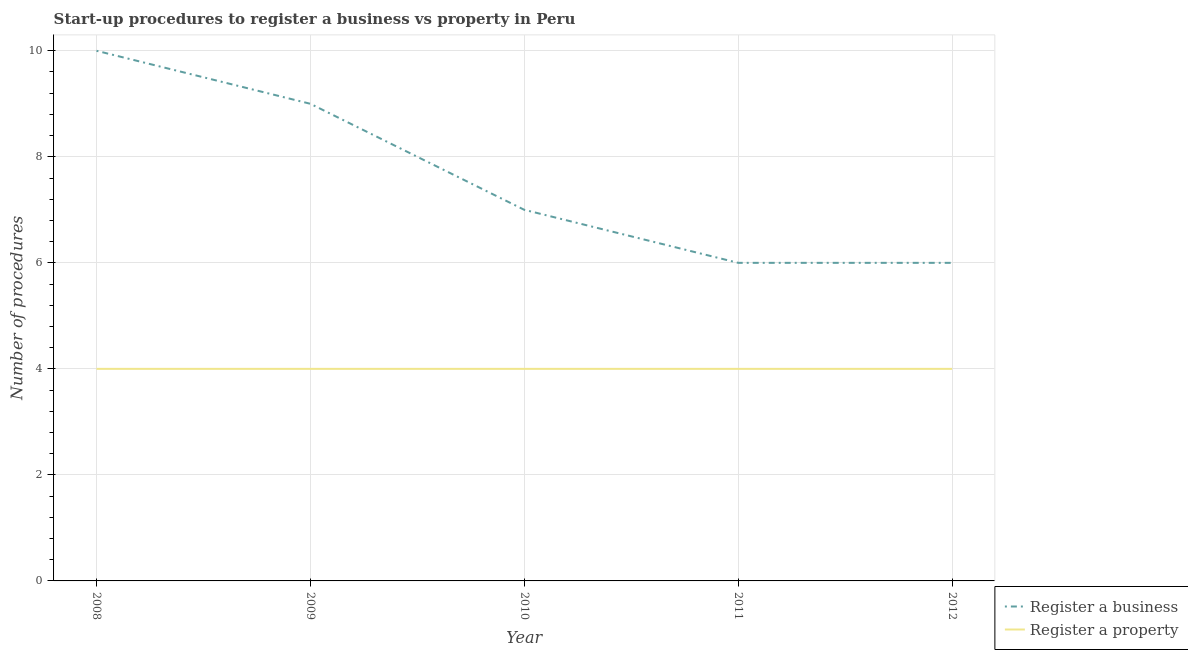How many different coloured lines are there?
Your response must be concise. 2. Is the number of lines equal to the number of legend labels?
Make the answer very short. Yes. Across all years, what is the maximum number of procedures to register a property?
Ensure brevity in your answer.  4. What is the total number of procedures to register a business in the graph?
Provide a succinct answer. 38. What is the difference between the number of procedures to register a business in 2011 and that in 2012?
Provide a short and direct response. 0. What is the average number of procedures to register a property per year?
Provide a short and direct response. 4. In the year 2011, what is the difference between the number of procedures to register a business and number of procedures to register a property?
Ensure brevity in your answer.  2. What is the ratio of the number of procedures to register a business in 2009 to that in 2010?
Give a very brief answer. 1.29. Is the number of procedures to register a property in 2011 less than that in 2012?
Give a very brief answer. No. Is the difference between the number of procedures to register a property in 2008 and 2011 greater than the difference between the number of procedures to register a business in 2008 and 2011?
Keep it short and to the point. No. What is the difference between the highest and the lowest number of procedures to register a business?
Your answer should be very brief. 4. In how many years, is the number of procedures to register a business greater than the average number of procedures to register a business taken over all years?
Offer a very short reply. 2. Does the number of procedures to register a business monotonically increase over the years?
Make the answer very short. No. Is the number of procedures to register a business strictly less than the number of procedures to register a property over the years?
Make the answer very short. No. How many lines are there?
Provide a short and direct response. 2. How many years are there in the graph?
Your answer should be very brief. 5. Are the values on the major ticks of Y-axis written in scientific E-notation?
Your answer should be very brief. No. Where does the legend appear in the graph?
Your response must be concise. Bottom right. How are the legend labels stacked?
Your answer should be compact. Vertical. What is the title of the graph?
Ensure brevity in your answer.  Start-up procedures to register a business vs property in Peru. What is the label or title of the X-axis?
Keep it short and to the point. Year. What is the label or title of the Y-axis?
Give a very brief answer. Number of procedures. What is the Number of procedures in Register a business in 2008?
Give a very brief answer. 10. What is the Number of procedures of Register a business in 2009?
Your answer should be very brief. 9. What is the Number of procedures of Register a property in 2009?
Offer a terse response. 4. What is the Number of procedures of Register a property in 2010?
Provide a succinct answer. 4. What is the Number of procedures in Register a business in 2011?
Your response must be concise. 6. What is the Number of procedures in Register a property in 2011?
Keep it short and to the point. 4. What is the Number of procedures in Register a business in 2012?
Offer a terse response. 6. What is the Number of procedures of Register a property in 2012?
Your answer should be compact. 4. Across all years, what is the maximum Number of procedures in Register a business?
Make the answer very short. 10. Across all years, what is the maximum Number of procedures of Register a property?
Give a very brief answer. 4. Across all years, what is the minimum Number of procedures of Register a business?
Provide a short and direct response. 6. Across all years, what is the minimum Number of procedures of Register a property?
Offer a very short reply. 4. What is the total Number of procedures of Register a business in the graph?
Provide a succinct answer. 38. What is the difference between the Number of procedures in Register a property in 2008 and that in 2011?
Your answer should be very brief. 0. What is the difference between the Number of procedures in Register a property in 2008 and that in 2012?
Make the answer very short. 0. What is the difference between the Number of procedures of Register a property in 2009 and that in 2010?
Provide a succinct answer. 0. What is the difference between the Number of procedures in Register a business in 2009 and that in 2011?
Offer a terse response. 3. What is the difference between the Number of procedures of Register a property in 2009 and that in 2012?
Keep it short and to the point. 0. What is the difference between the Number of procedures in Register a business in 2010 and that in 2011?
Provide a short and direct response. 1. What is the difference between the Number of procedures in Register a business in 2010 and that in 2012?
Provide a short and direct response. 1. What is the difference between the Number of procedures of Register a property in 2010 and that in 2012?
Your response must be concise. 0. What is the difference between the Number of procedures in Register a business in 2011 and that in 2012?
Offer a terse response. 0. What is the difference between the Number of procedures of Register a business in 2008 and the Number of procedures of Register a property in 2011?
Your response must be concise. 6. What is the difference between the Number of procedures of Register a business in 2010 and the Number of procedures of Register a property in 2011?
Keep it short and to the point. 3. What is the average Number of procedures of Register a property per year?
Ensure brevity in your answer.  4. What is the ratio of the Number of procedures of Register a business in 2008 to that in 2009?
Give a very brief answer. 1.11. What is the ratio of the Number of procedures of Register a business in 2008 to that in 2010?
Offer a very short reply. 1.43. What is the ratio of the Number of procedures in Register a business in 2008 to that in 2011?
Make the answer very short. 1.67. What is the ratio of the Number of procedures of Register a property in 2008 to that in 2011?
Make the answer very short. 1. What is the ratio of the Number of procedures of Register a business in 2008 to that in 2012?
Your answer should be very brief. 1.67. What is the ratio of the Number of procedures in Register a business in 2009 to that in 2010?
Ensure brevity in your answer.  1.29. What is the ratio of the Number of procedures in Register a property in 2009 to that in 2010?
Provide a succinct answer. 1. What is the ratio of the Number of procedures of Register a property in 2009 to that in 2011?
Offer a very short reply. 1. What is the ratio of the Number of procedures in Register a property in 2009 to that in 2012?
Offer a very short reply. 1. What is the ratio of the Number of procedures of Register a business in 2010 to that in 2011?
Your answer should be very brief. 1.17. What is the ratio of the Number of procedures of Register a property in 2010 to that in 2011?
Provide a short and direct response. 1. What is the ratio of the Number of procedures in Register a property in 2010 to that in 2012?
Make the answer very short. 1. What is the ratio of the Number of procedures of Register a business in 2011 to that in 2012?
Give a very brief answer. 1. What is the difference between the highest and the lowest Number of procedures of Register a property?
Make the answer very short. 0. 